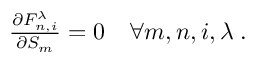<formula> <loc_0><loc_0><loc_500><loc_500>\begin{array} { r } { \frac { \partial F _ { n , i } ^ { \lambda } } { \partial S _ { m } } = 0 \quad \forall m , n , i , \lambda \, . } \end{array}</formula> 